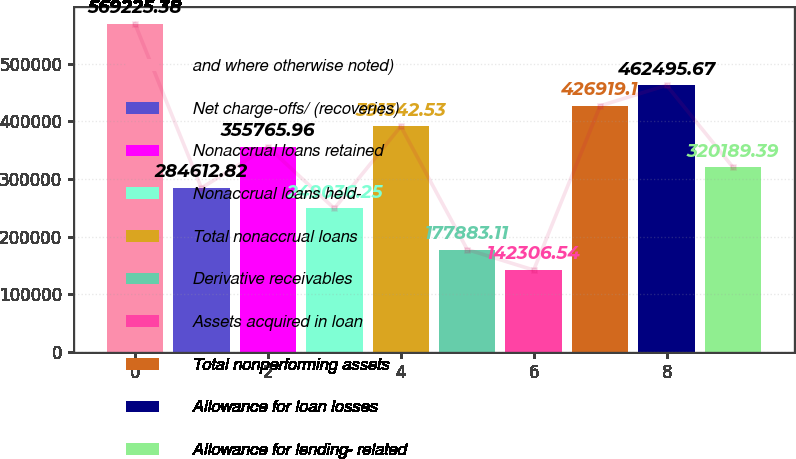Convert chart to OTSL. <chart><loc_0><loc_0><loc_500><loc_500><bar_chart><fcel>and where otherwise noted)<fcel>Net charge-offs/ (recoveries)<fcel>Nonaccrual loans retained<fcel>Nonaccrual loans held-<fcel>Total nonaccrual loans<fcel>Derivative receivables<fcel>Assets acquired in loan<fcel>Total nonperforming assets<fcel>Allowance for loan losses<fcel>Allowance for lending- related<nl><fcel>569225<fcel>284613<fcel>355766<fcel>249036<fcel>391343<fcel>177883<fcel>142307<fcel>426919<fcel>462496<fcel>320189<nl></chart> 